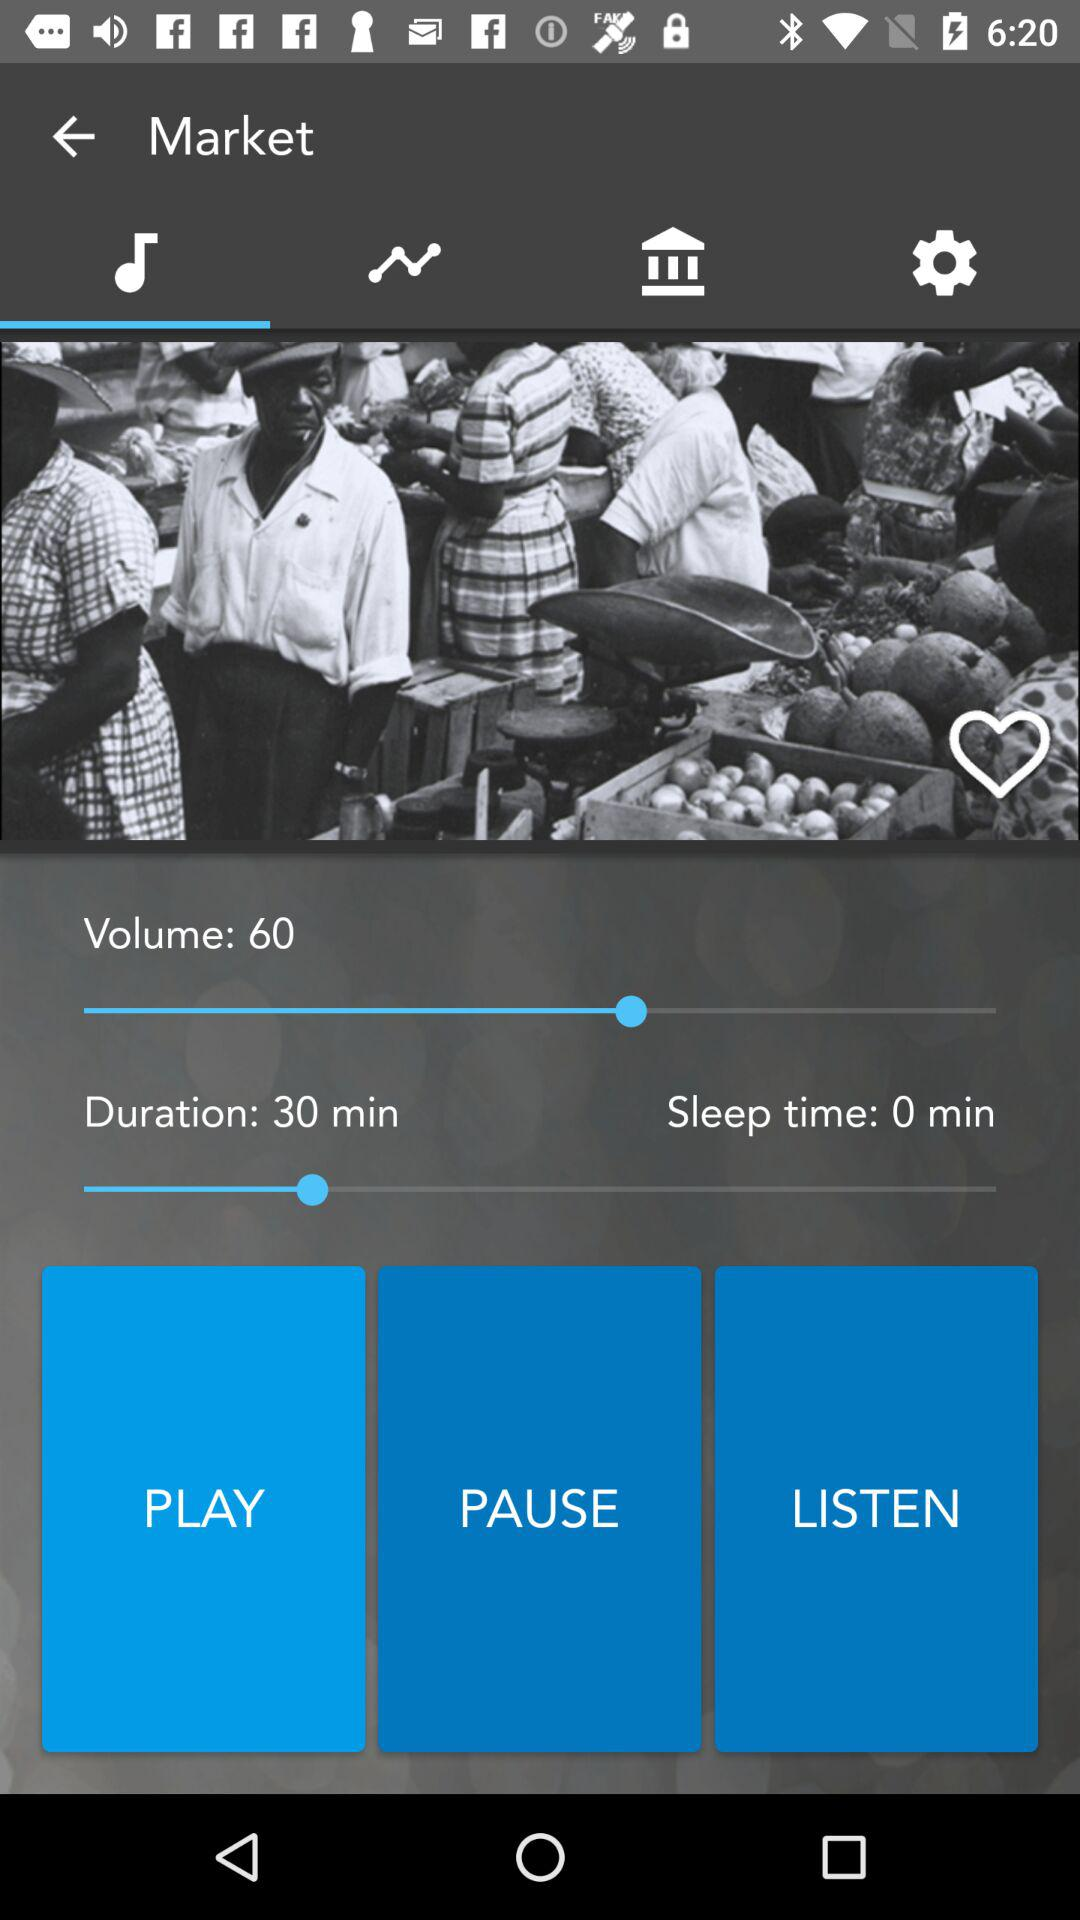What is the sleep time? The sleep time is 0 minutes. 